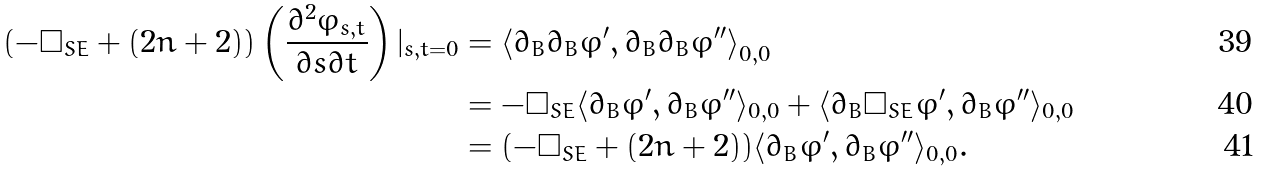Convert formula to latex. <formula><loc_0><loc_0><loc_500><loc_500>( - \Box _ { S E } + ( 2 n + 2 ) ) \left ( \frac { \partial ^ { 2 } \varphi _ { s , t } } { \partial s \partial t } \right ) | _ { s , t = 0 } & = \left \langle \partial _ { B } \bar { \partial } _ { B } \varphi ^ { \prime } , \partial _ { B } \bar { \partial } _ { B } \varphi ^ { \prime \prime } \right \rangle _ { 0 , 0 } \\ & = - \Box _ { S E } \langle \partial _ { B } \varphi ^ { \prime } , \partial _ { B } \varphi ^ { \prime \prime } \rangle _ { 0 , 0 } + \langle \partial _ { B } \Box _ { S E } \varphi ^ { \prime } , \partial _ { B } \varphi ^ { \prime \prime } \rangle _ { 0 , 0 } \\ & = ( - \Box _ { S E } + ( 2 n + 2 ) ) \langle \partial _ { B } \varphi ^ { \prime } , \partial _ { B } \varphi ^ { \prime \prime } \rangle _ { 0 , 0 } .</formula> 